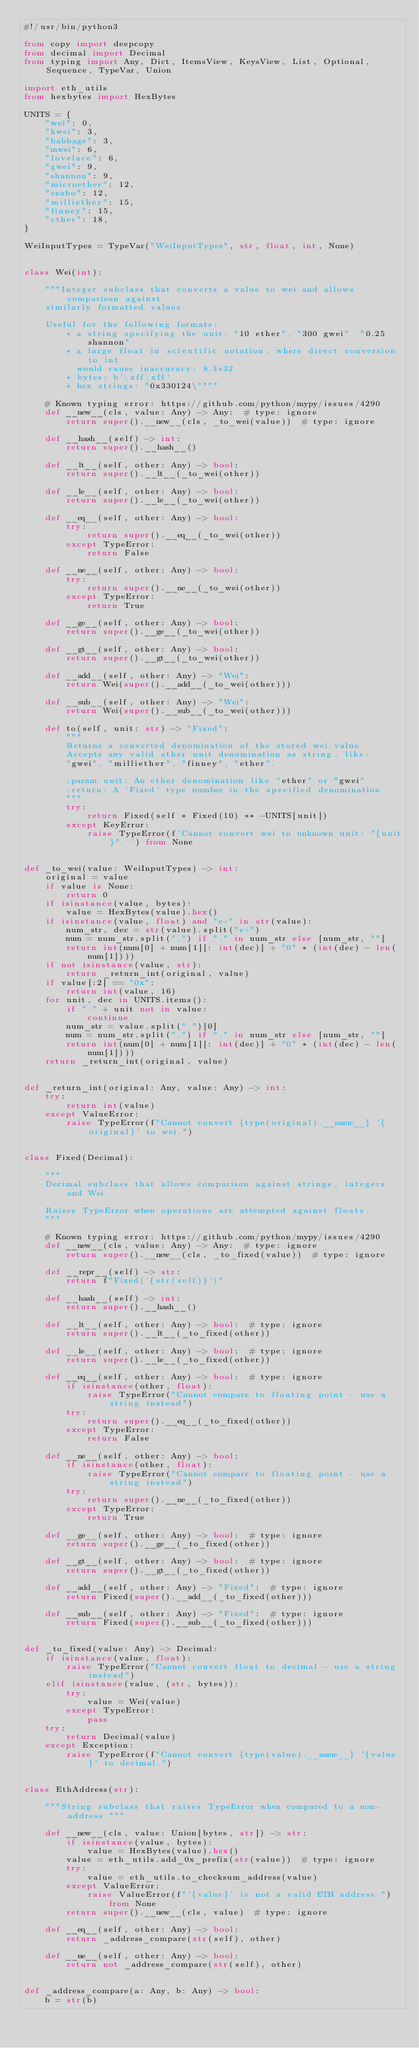Convert code to text. <code><loc_0><loc_0><loc_500><loc_500><_Python_>#!/usr/bin/python3

from copy import deepcopy
from decimal import Decimal
from typing import Any, Dict, ItemsView, KeysView, List, Optional, Sequence, TypeVar, Union

import eth_utils
from hexbytes import HexBytes

UNITS = {
    "wei": 0,
    "kwei": 3,
    "babbage": 3,
    "mwei": 6,
    "lovelace": 6,
    "gwei": 9,
    "shannon": 9,
    "microether": 12,
    "szabo": 12,
    "milliether": 15,
    "finney": 15,
    "ether": 18,
}

WeiInputTypes = TypeVar("WeiInputTypes", str, float, int, None)


class Wei(int):

    """Integer subclass that converts a value to wei and allows comparison against
    similarly formatted values.

    Useful for the following formats:
        * a string specifying the unit: "10 ether", "300 gwei", "0.25 shannon"
        * a large float in scientific notation, where direct conversion to int
          would cause inaccuracy: 8.3e32
        * bytes: b'\xff\xff'
        * hex strings: "0x330124\""""

    # Known typing error: https://github.com/python/mypy/issues/4290
    def __new__(cls, value: Any) -> Any:  # type: ignore
        return super().__new__(cls, _to_wei(value))  # type: ignore

    def __hash__(self) -> int:
        return super().__hash__()

    def __lt__(self, other: Any) -> bool:
        return super().__lt__(_to_wei(other))

    def __le__(self, other: Any) -> bool:
        return super().__le__(_to_wei(other))

    def __eq__(self, other: Any) -> bool:
        try:
            return super().__eq__(_to_wei(other))
        except TypeError:
            return False

    def __ne__(self, other: Any) -> bool:
        try:
            return super().__ne__(_to_wei(other))
        except TypeError:
            return True

    def __ge__(self, other: Any) -> bool:
        return super().__ge__(_to_wei(other))

    def __gt__(self, other: Any) -> bool:
        return super().__gt__(_to_wei(other))

    def __add__(self, other: Any) -> "Wei":
        return Wei(super().__add__(_to_wei(other)))

    def __sub__(self, other: Any) -> "Wei":
        return Wei(super().__sub__(_to_wei(other)))

    def to(self, unit: str) -> "Fixed":
        """
        Returns a converted denomination of the stored wei value.
        Accepts any valid ether unit denomination as string, like:
        "gwei", "milliether", "finney", "ether".

        :param unit: An ether denomination like "ether" or "gwei"
        :return: A 'Fixed' type number in the specified denomination
        """
        try:
            return Fixed(self * Fixed(10) ** -UNITS[unit])
        except KeyError:
            raise TypeError(f'Cannot convert wei to unknown unit: "{unit}". ') from None


def _to_wei(value: WeiInputTypes) -> int:
    original = value
    if value is None:
        return 0
    if isinstance(value, bytes):
        value = HexBytes(value).hex()
    if isinstance(value, float) and "e+" in str(value):
        num_str, dec = str(value).split("e+")
        num = num_str.split(".") if "." in num_str else [num_str, ""]
        return int(num[0] + num[1][: int(dec)] + "0" * (int(dec) - len(num[1])))
    if not isinstance(value, str):
        return _return_int(original, value)
    if value[:2] == "0x":
        return int(value, 16)
    for unit, dec in UNITS.items():
        if " " + unit not in value:
            continue
        num_str = value.split(" ")[0]
        num = num_str.split(".") if "." in num_str else [num_str, ""]
        return int(num[0] + num[1][: int(dec)] + "0" * (int(dec) - len(num[1])))
    return _return_int(original, value)


def _return_int(original: Any, value: Any) -> int:
    try:
        return int(value)
    except ValueError:
        raise TypeError(f"Cannot convert {type(original).__name__} '{original}' to wei.")


class Fixed(Decimal):

    """
    Decimal subclass that allows comparison against strings, integers and Wei.

    Raises TypeError when operations are attempted against floats.
    """

    # Known typing error: https://github.com/python/mypy/issues/4290
    def __new__(cls, value: Any) -> Any:  # type: ignore
        return super().__new__(cls, _to_fixed(value))  # type: ignore

    def __repr__(self) -> str:
        return f"Fixed('{str(self)}')"

    def __hash__(self) -> int:
        return super().__hash__()

    def __lt__(self, other: Any) -> bool:  # type: ignore
        return super().__lt__(_to_fixed(other))

    def __le__(self, other: Any) -> bool:  # type: ignore
        return super().__le__(_to_fixed(other))

    def __eq__(self, other: Any) -> bool:  # type: ignore
        if isinstance(other, float):
            raise TypeError("Cannot compare to floating point - use a string instead")
        try:
            return super().__eq__(_to_fixed(other))
        except TypeError:
            return False

    def __ne__(self, other: Any) -> bool:
        if isinstance(other, float):
            raise TypeError("Cannot compare to floating point - use a string instead")
        try:
            return super().__ne__(_to_fixed(other))
        except TypeError:
            return True

    def __ge__(self, other: Any) -> bool:  # type: ignore
        return super().__ge__(_to_fixed(other))

    def __gt__(self, other: Any) -> bool:  # type: ignore
        return super().__gt__(_to_fixed(other))

    def __add__(self, other: Any) -> "Fixed":  # type: ignore
        return Fixed(super().__add__(_to_fixed(other)))

    def __sub__(self, other: Any) -> "Fixed":  # type: ignore
        return Fixed(super().__sub__(_to_fixed(other)))


def _to_fixed(value: Any) -> Decimal:
    if isinstance(value, float):
        raise TypeError("Cannot convert float to decimal - use a string instead")
    elif isinstance(value, (str, bytes)):
        try:
            value = Wei(value)
        except TypeError:
            pass
    try:
        return Decimal(value)
    except Exception:
        raise TypeError(f"Cannot convert {type(value).__name__} '{value}' to decimal.")


class EthAddress(str):

    """String subclass that raises TypeError when compared to a non-address."""

    def __new__(cls, value: Union[bytes, str]) -> str:
        if isinstance(value, bytes):
            value = HexBytes(value).hex()
        value = eth_utils.add_0x_prefix(str(value))  # type: ignore
        try:
            value = eth_utils.to_checksum_address(value)
        except ValueError:
            raise ValueError(f"'{value}' is not a valid ETH address.") from None
        return super().__new__(cls, value)  # type: ignore

    def __eq__(self, other: Any) -> bool:
        return _address_compare(str(self), other)

    def __ne__(self, other: Any) -> bool:
        return not _address_compare(str(self), other)


def _address_compare(a: Any, b: Any) -> bool:
    b = str(b)</code> 